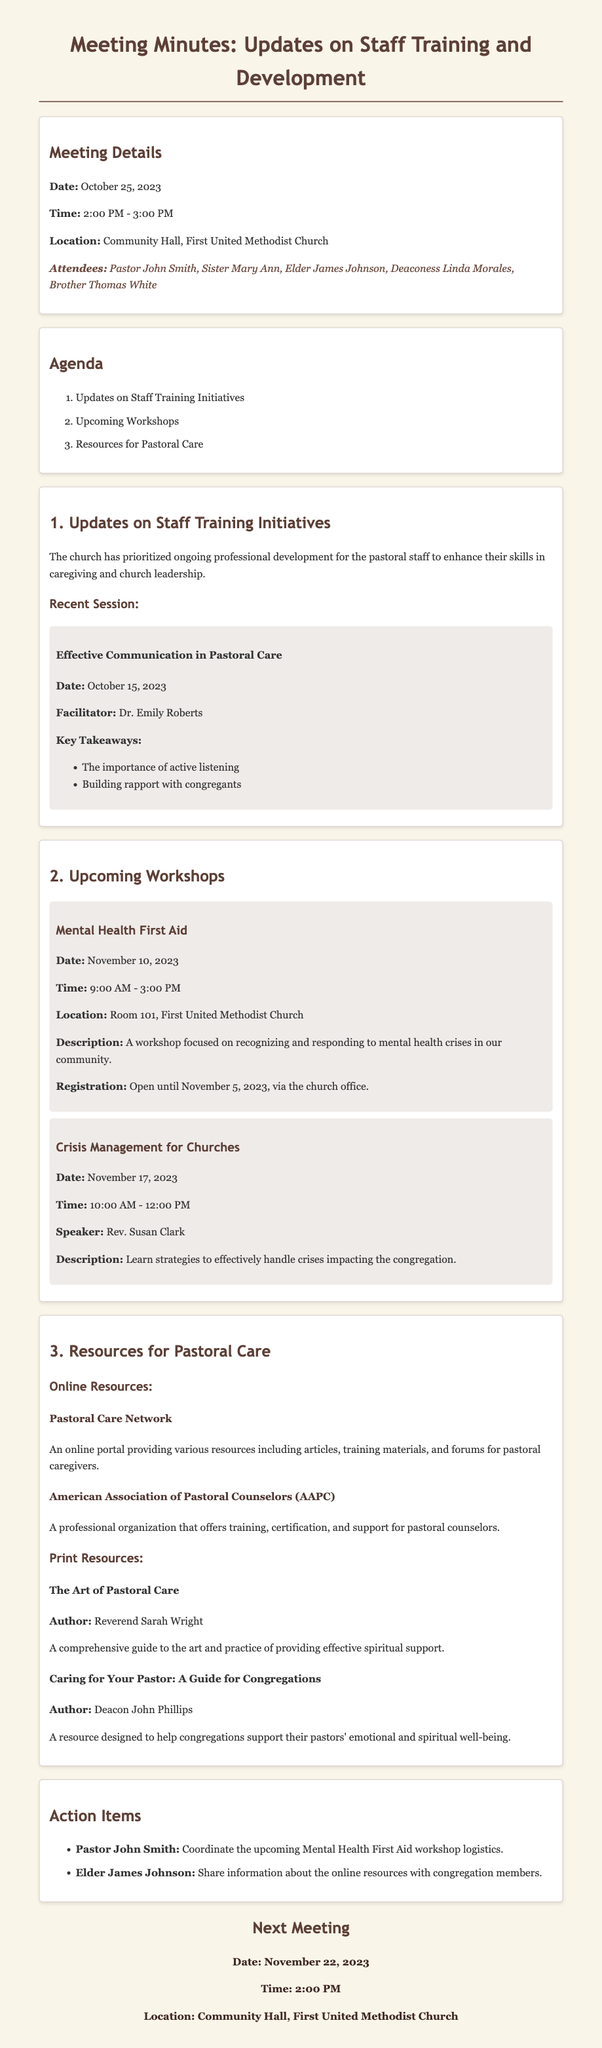What is the date of the next meeting? The next meeting date is clearly stated in the "Next Meeting" section of the document.
Answer: November 22, 2023 Who facilitated the recent workshop on effective communication? The facilitator for the recent workshop is mentioned in the "Recent Session" subsection.
Answer: Dr. Emily Roberts What is the time for the Mental Health First Aid workshop? The time for the workshop is listed in the "Upcoming Workshops" section under that specific workshop.
Answer: 9:00 AM - 3:00 PM Which online resource is provided by the American Association of Pastoral Counselors? The specific online resource is detailed in the "Online Resources" subsection.
Answer: American Association of Pastoral Counselors (AAPC) What is the main focus of the Crisis Management for Churches workshop? This information is included in the description of the workshop in the "Upcoming Workshops" section.
Answer: Learn strategies to effectively handle crises impacting the congregation Who is responsible for coordinating the Mental Health First Aid workshop logistics? The action item specifies who is responsible for this task.
Answer: Pastor John Smith What is a key takeaway from the Effective Communication in Pastoral Care workshop? The key takeaway is highlighted in the bullet points listed under the recent session.
Answer: The importance of active listening What type of resources is "The Art of Pastoral Care"? This detail is included in the "Print Resources" section of the document.
Answer: Print Resource 